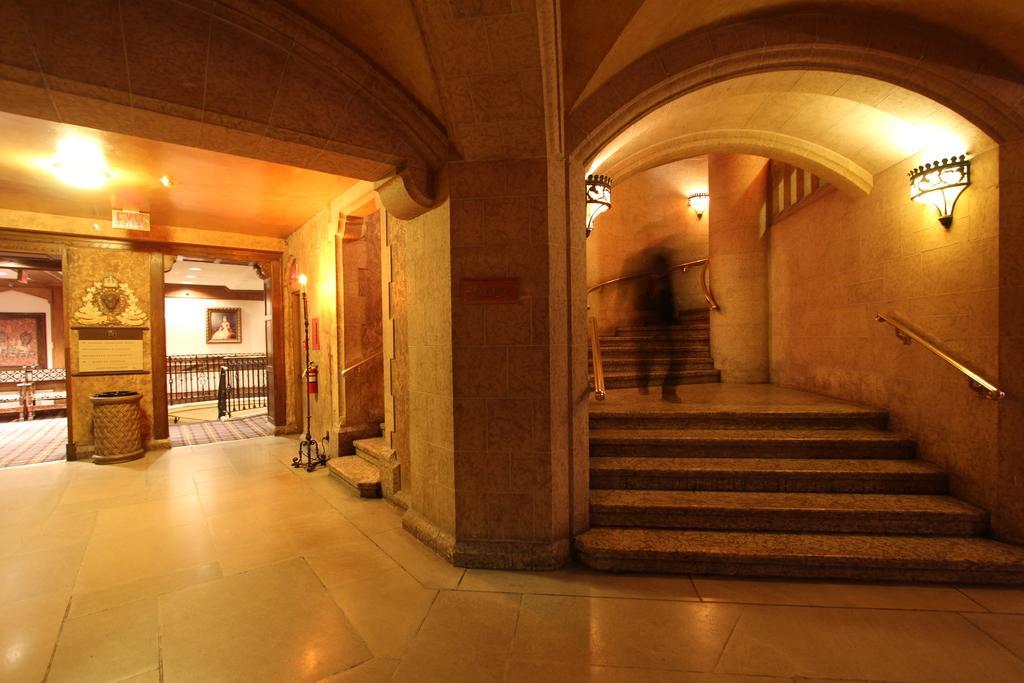In one or two sentences, can you explain what this image depicts? In this picture I can see inner view of a building and I can see a photo frame on the wall and a stand light and I can see few lights on the ceiling and I can see stairs and few lights on the wall 